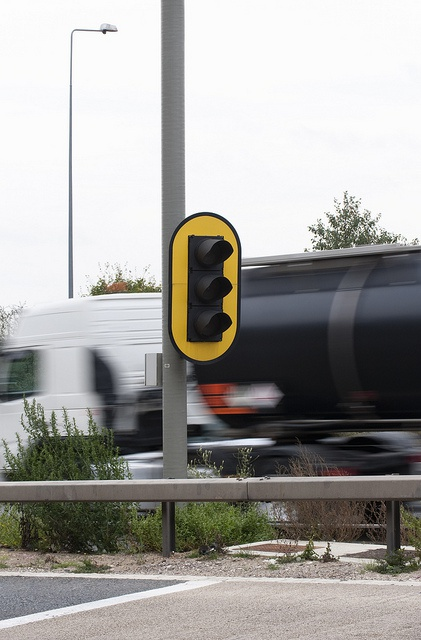Describe the objects in this image and their specific colors. I can see train in white, black, gray, lightgray, and darkgray tones and traffic light in white, black, orange, and olive tones in this image. 